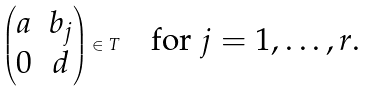Convert formula to latex. <formula><loc_0><loc_0><loc_500><loc_500>\begin{pmatrix} a & b _ { j } \\ 0 & d \end{pmatrix} \in T \quad \text {for $j=1,\dots,r$.}</formula> 